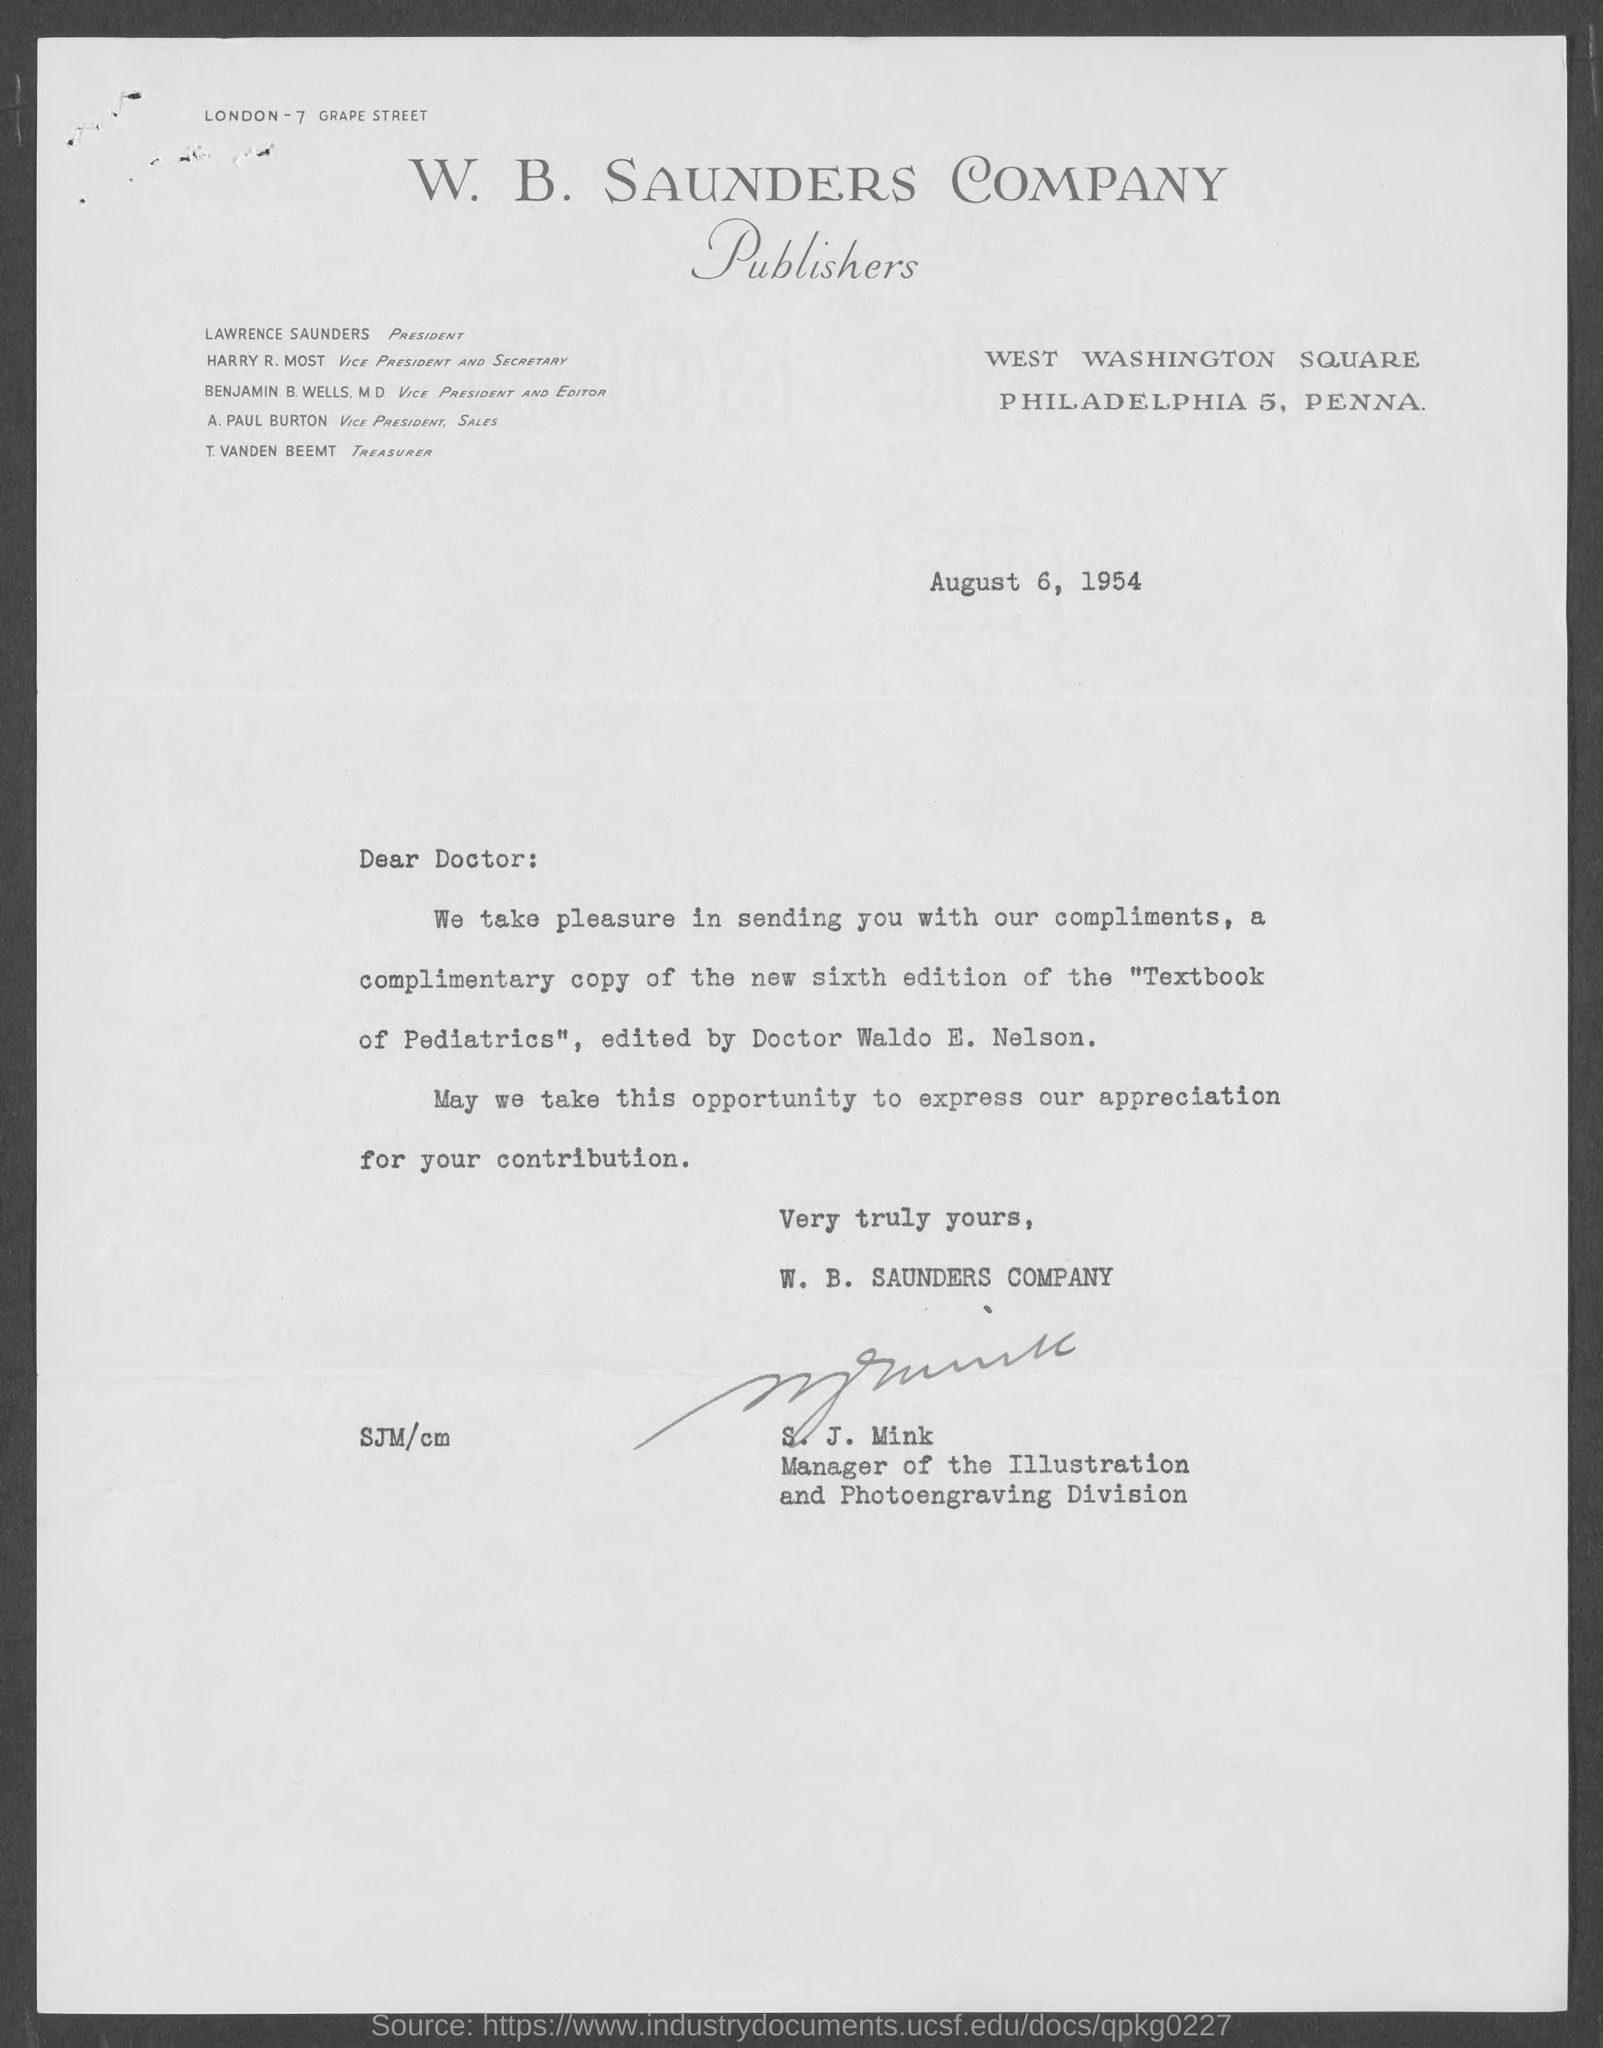Draw attention to some important aspects in this diagram. The Vice President and Editor of the journal is Benjamin B. Wells, M.D. T. Vanden Beemt is the Treasurer. The Vice President and Secretary is Harry R. Most. I, Paul Burton, am the Vice President of Sales. Lawrence Saunders is the President. 